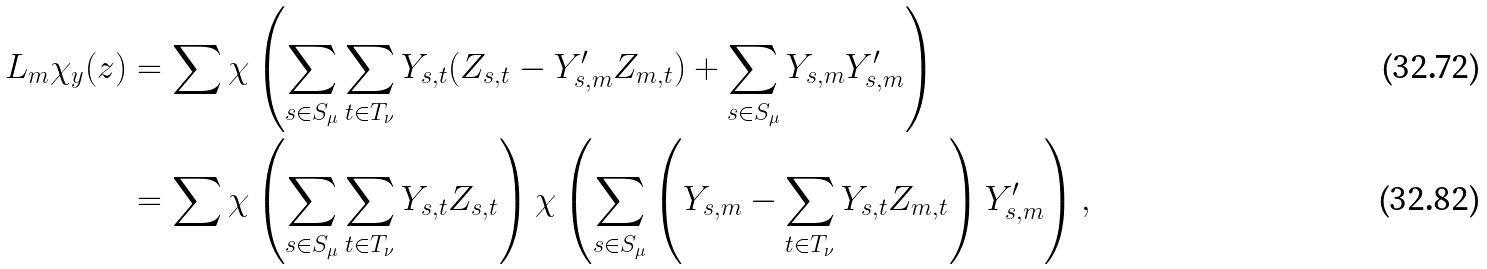Convert formula to latex. <formula><loc_0><loc_0><loc_500><loc_500>L _ { m } \chi _ { y } ( z ) & = \sum \chi \left ( \sum _ { s \in S _ { \mu } } \sum _ { t \in T _ { \nu } } Y _ { s , t } ( Z _ { s , t } - Y ^ { \prime } _ { s , m } Z _ { m , t } ) + \sum _ { s \in S _ { \mu } } Y _ { s , m } Y ^ { \prime } _ { s , m } \right ) \\ & = \sum \chi \left ( \sum _ { s \in S _ { \mu } } \sum _ { t \in T _ { \nu } } Y _ { s , t } Z _ { s , t } \right ) \chi \left ( \sum _ { s \in S _ { \mu } } \left ( Y _ { s , m } - \sum _ { t \in T _ { \nu } } Y _ { s , t } Z _ { m , t } \right ) Y ^ { \prime } _ { s , m } \right ) ,</formula> 